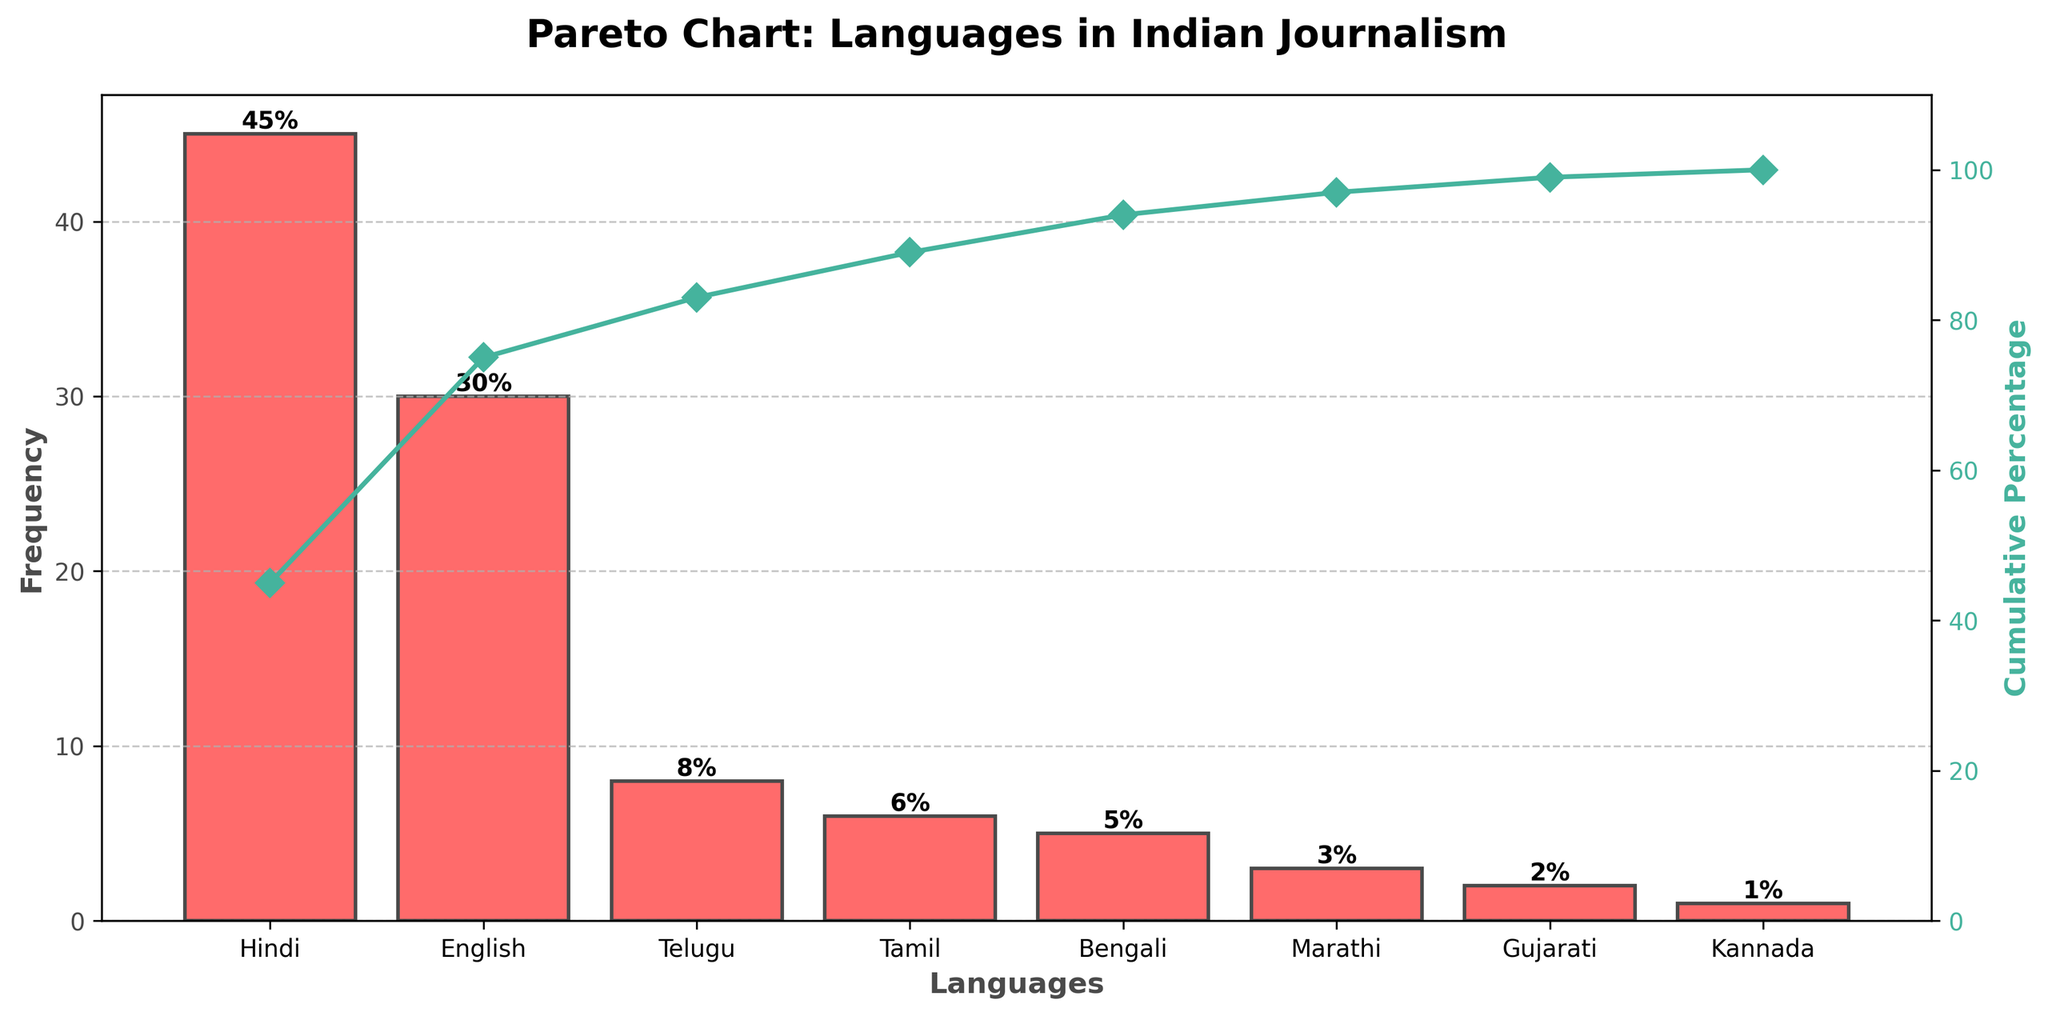What is the frequency of Hindi in national broadcasts? The bar chart shows that the frequency of Hindi is marked at the top of the tallest bar on the left. This bar indicates a frequency of 45.
Answer: 45 Which language has the second-highest frequency of use? By observing the bar heights from left to right, the second tallest bar represents English with a frequency of 30.
Answer: English What is the cumulative percentage after adding the frequency of Hindi and English? To find the cumulative percentage, we add the frequencies of Hindi and English: 45 (Hindi) + 30 (English) = 75. The cumulative percentage line at this point is approximately 75/100 * 100% = 75%.
Answer: 75% Which language has the lowest frequency of use? The bar on the far right represents Kannada, which has the shortest height indicating a frequency of 1.
Answer: Kannada What cumulative percentage is reached after Tamil is included? Adding the frequencies of Hindi (45), English (30), and Telugu (8) along with Tamil (6), we get a total of 45 + 30 + 8 + 6 = 89. This translates to a cumulative percentage of (89/100) * 100% = 89%.
Answer: 89% Which language's addition makes the cumulative percentage exceed 50%? We need to observe the cumulative percentage line crossing 50%. Adding Hindi gives 45%, then adding English reaches 75%, so English is the language that causes the cumulative percentage to exceed 50%.
Answer: English By how much does the frequency of Hindi exceed that of Bengali? From the figure, Hindi has a frequency of 45 and Bengali has 5. The difference is 45 - 5 = 40.
Answer: 40 How many languages together make up more than 80% of the total frequency? We start adding the frequencies from highest to lowest: Hindi (45), English (30), Telugu (8). Adding these gives 45 + 30 + 8 = 83, which is more than 80%. Therefore, it takes three languages.
Answer: 3 What percentage of the total does Marathi contribute? Marathi's frequency is 3. Total frequency is 100. The percentage is (3/100) * 100% = 3%.
Answer: 3% Is Tamil's frequency greater than or equal to twice that of Gujarati? Tamil has a frequency of 6, and Gujarati has a frequency of 2. Twice Gujarati’s frequency is 2 * 2 = 4. Since 6 > 4, Tamil's frequency is greater than twice that of Gujarati.
Answer: Yes 